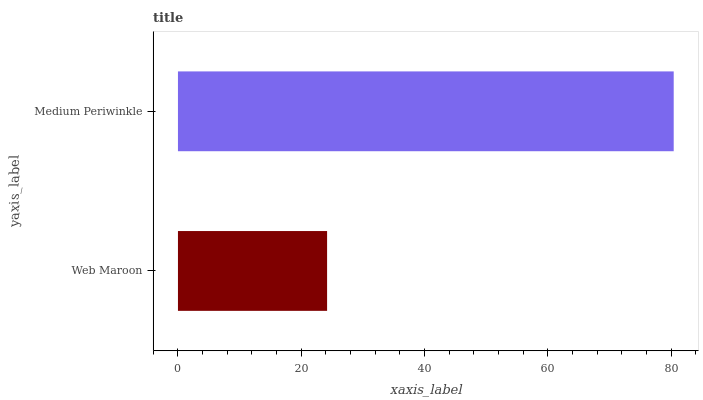Is Web Maroon the minimum?
Answer yes or no. Yes. Is Medium Periwinkle the maximum?
Answer yes or no. Yes. Is Medium Periwinkle the minimum?
Answer yes or no. No. Is Medium Periwinkle greater than Web Maroon?
Answer yes or no. Yes. Is Web Maroon less than Medium Periwinkle?
Answer yes or no. Yes. Is Web Maroon greater than Medium Periwinkle?
Answer yes or no. No. Is Medium Periwinkle less than Web Maroon?
Answer yes or no. No. Is Medium Periwinkle the high median?
Answer yes or no. Yes. Is Web Maroon the low median?
Answer yes or no. Yes. Is Web Maroon the high median?
Answer yes or no. No. Is Medium Periwinkle the low median?
Answer yes or no. No. 